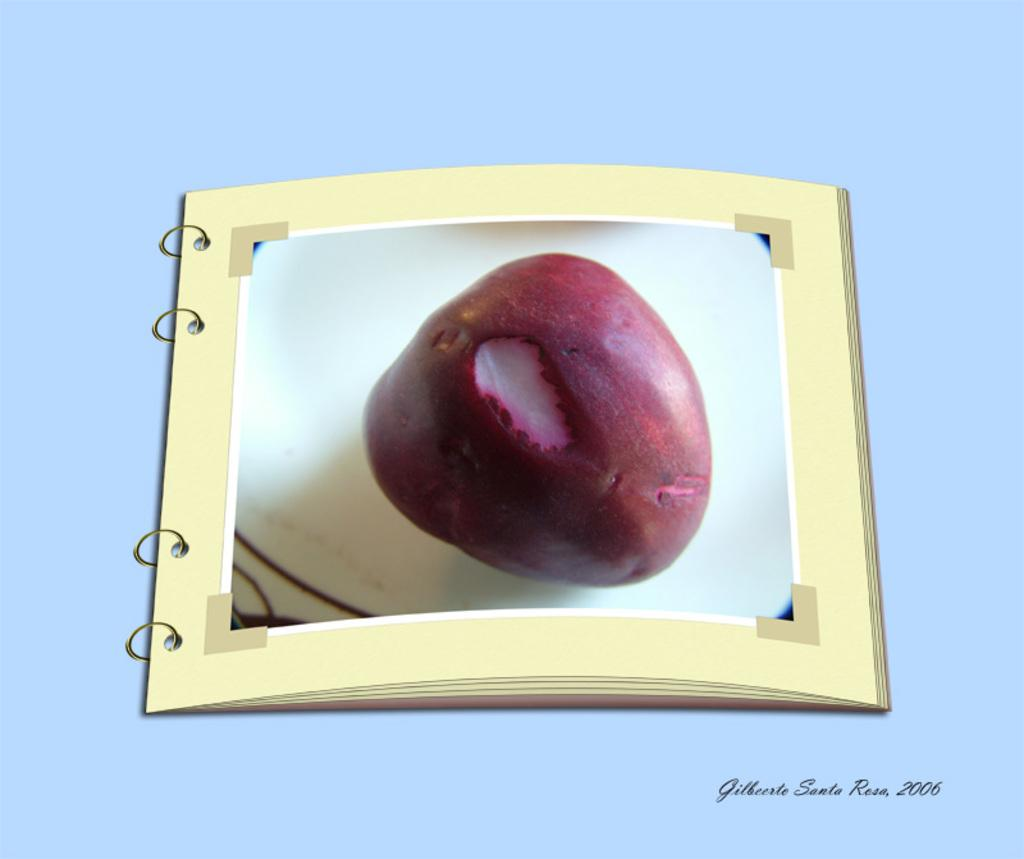What is the main subject of the image? The main subject of the image is a picture of a fruit. How much money is being exchanged in the image? There is no money being exchanged in the image; it only features a picture of a fruit. What type of crate is visible in the image? There is no crate present in the image; it only features a picture of a fruit. 